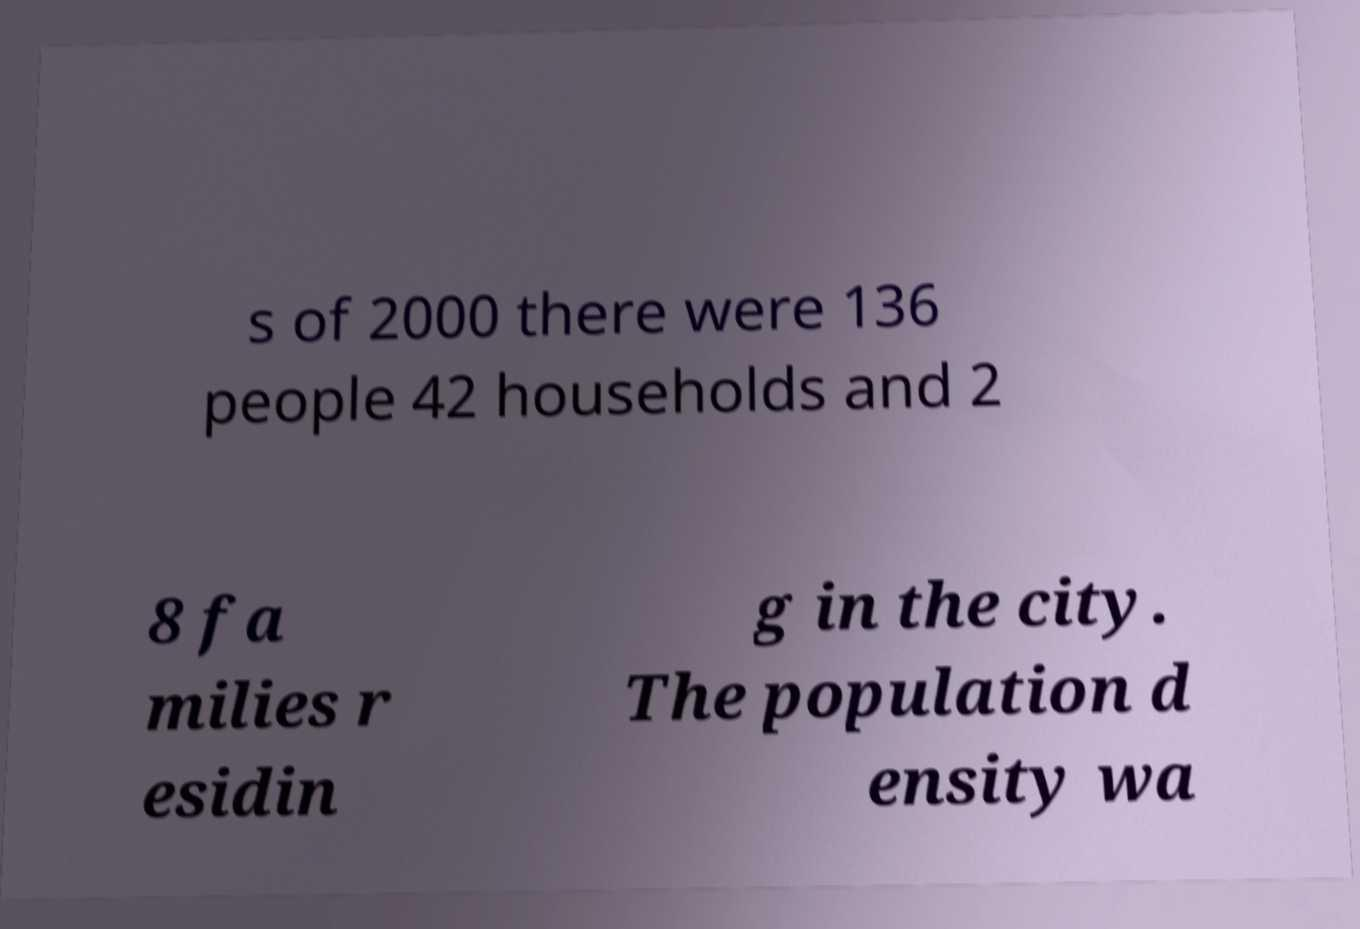For documentation purposes, I need the text within this image transcribed. Could you provide that? s of 2000 there were 136 people 42 households and 2 8 fa milies r esidin g in the city. The population d ensity wa 